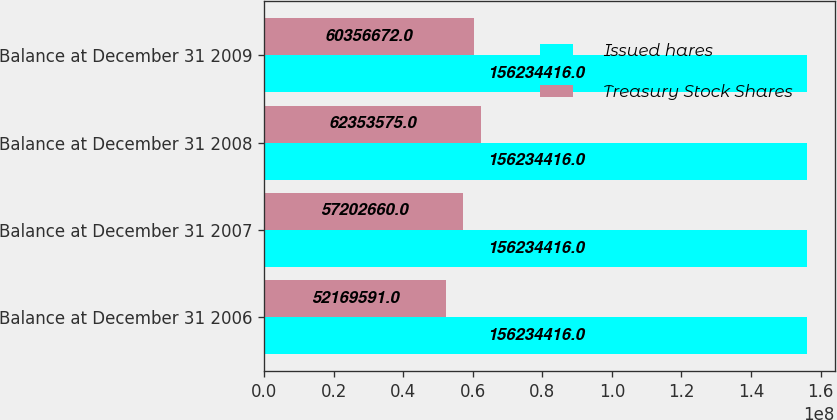Convert chart. <chart><loc_0><loc_0><loc_500><loc_500><stacked_bar_chart><ecel><fcel>Balance at December 31 2006<fcel>Balance at December 31 2007<fcel>Balance at December 31 2008<fcel>Balance at December 31 2009<nl><fcel>Issued hares<fcel>1.56234e+08<fcel>1.56234e+08<fcel>1.56234e+08<fcel>1.56234e+08<nl><fcel>Treasury Stock Shares<fcel>5.21696e+07<fcel>5.72027e+07<fcel>6.23536e+07<fcel>6.03567e+07<nl></chart> 